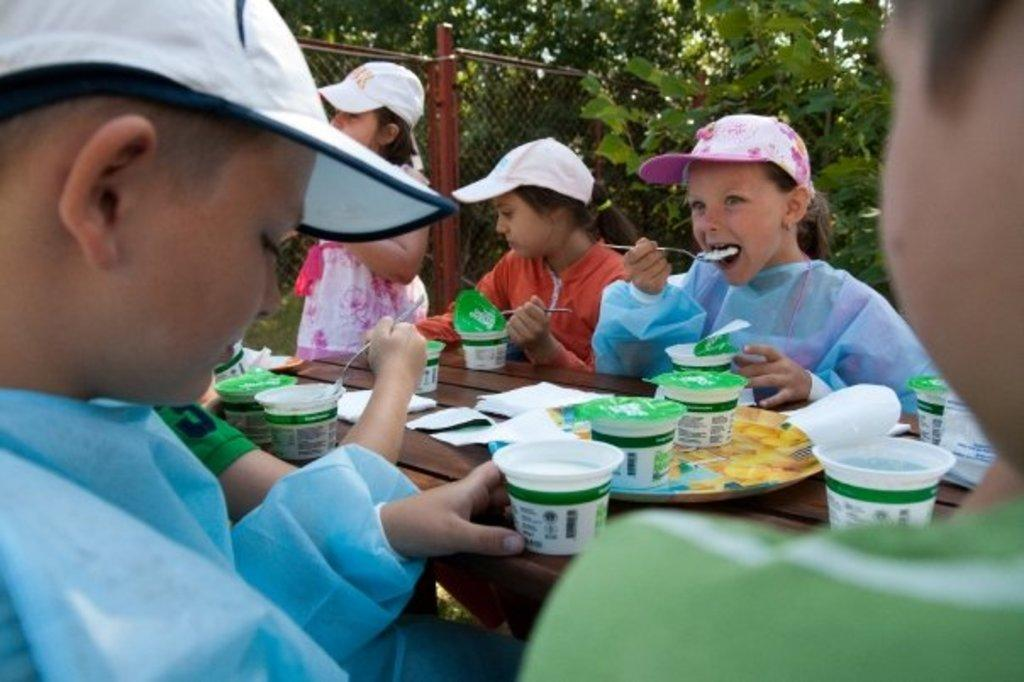What are the people in the image doing? There are people sitting in the image. What is the person on the left doing specifically? The person on the left is eating. What can be seen on the table in the image? There are cups on the table. What is visible in the background of the image? There are trees and fencing visible in the background. Can you see a cave in the image? No, there is no cave present in the image. 